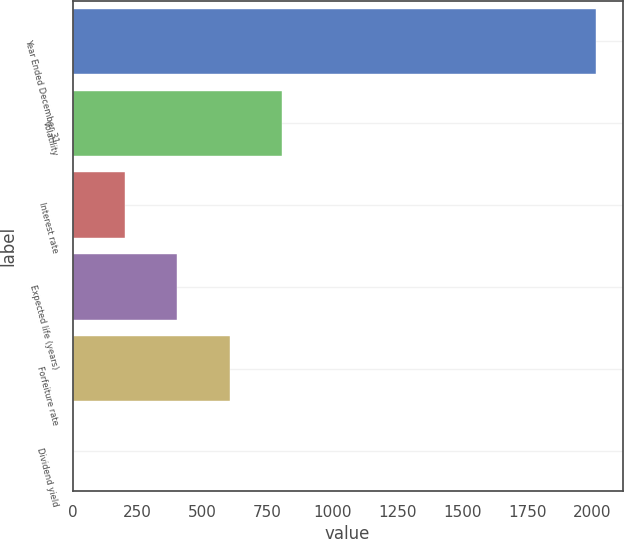<chart> <loc_0><loc_0><loc_500><loc_500><bar_chart><fcel>Year Ended December 31<fcel>Volatility<fcel>Interest rate<fcel>Expected life (years)<fcel>Forfeiture rate<fcel>Dividend yield<nl><fcel>2016<fcel>806.64<fcel>201.96<fcel>403.52<fcel>605.08<fcel>0.4<nl></chart> 